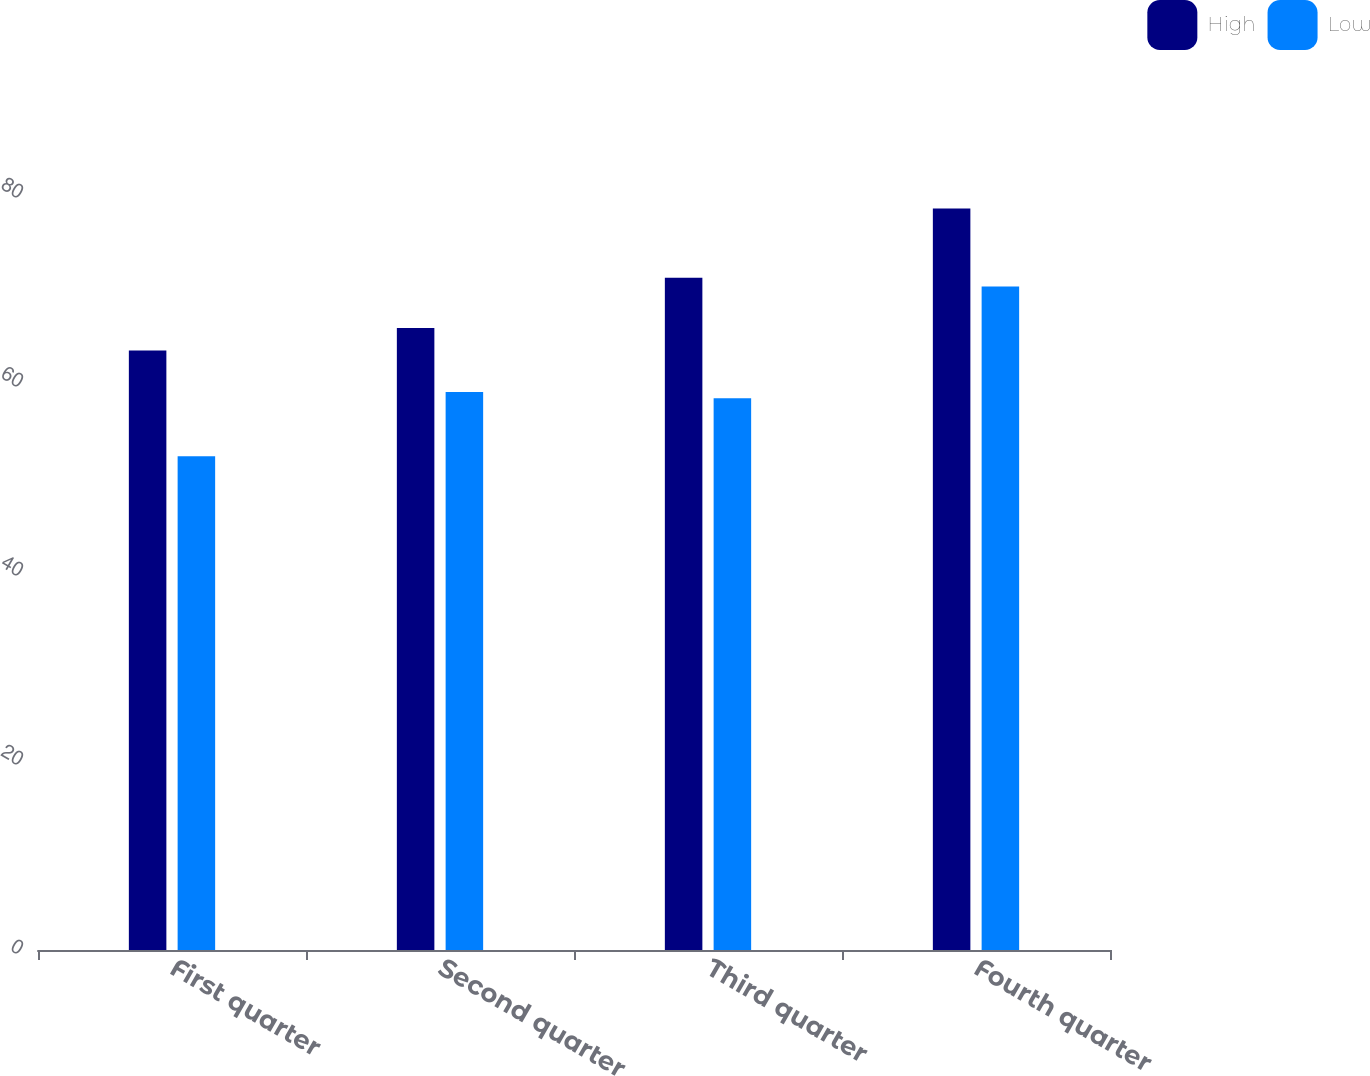<chart> <loc_0><loc_0><loc_500><loc_500><stacked_bar_chart><ecel><fcel>First quarter<fcel>Second quarter<fcel>Third quarter<fcel>Fourth quarter<nl><fcel>High<fcel>63.45<fcel>65.81<fcel>71.13<fcel>78.46<nl><fcel>Low<fcel>52.25<fcel>59.05<fcel>58.39<fcel>70.2<nl></chart> 